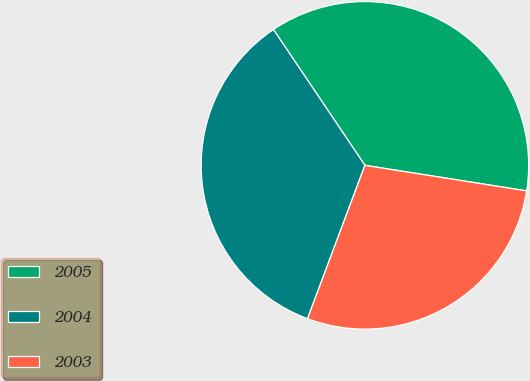Convert chart to OTSL. <chart><loc_0><loc_0><loc_500><loc_500><pie_chart><fcel>2005<fcel>2004<fcel>2003<nl><fcel>36.93%<fcel>34.87%<fcel>28.21%<nl></chart> 